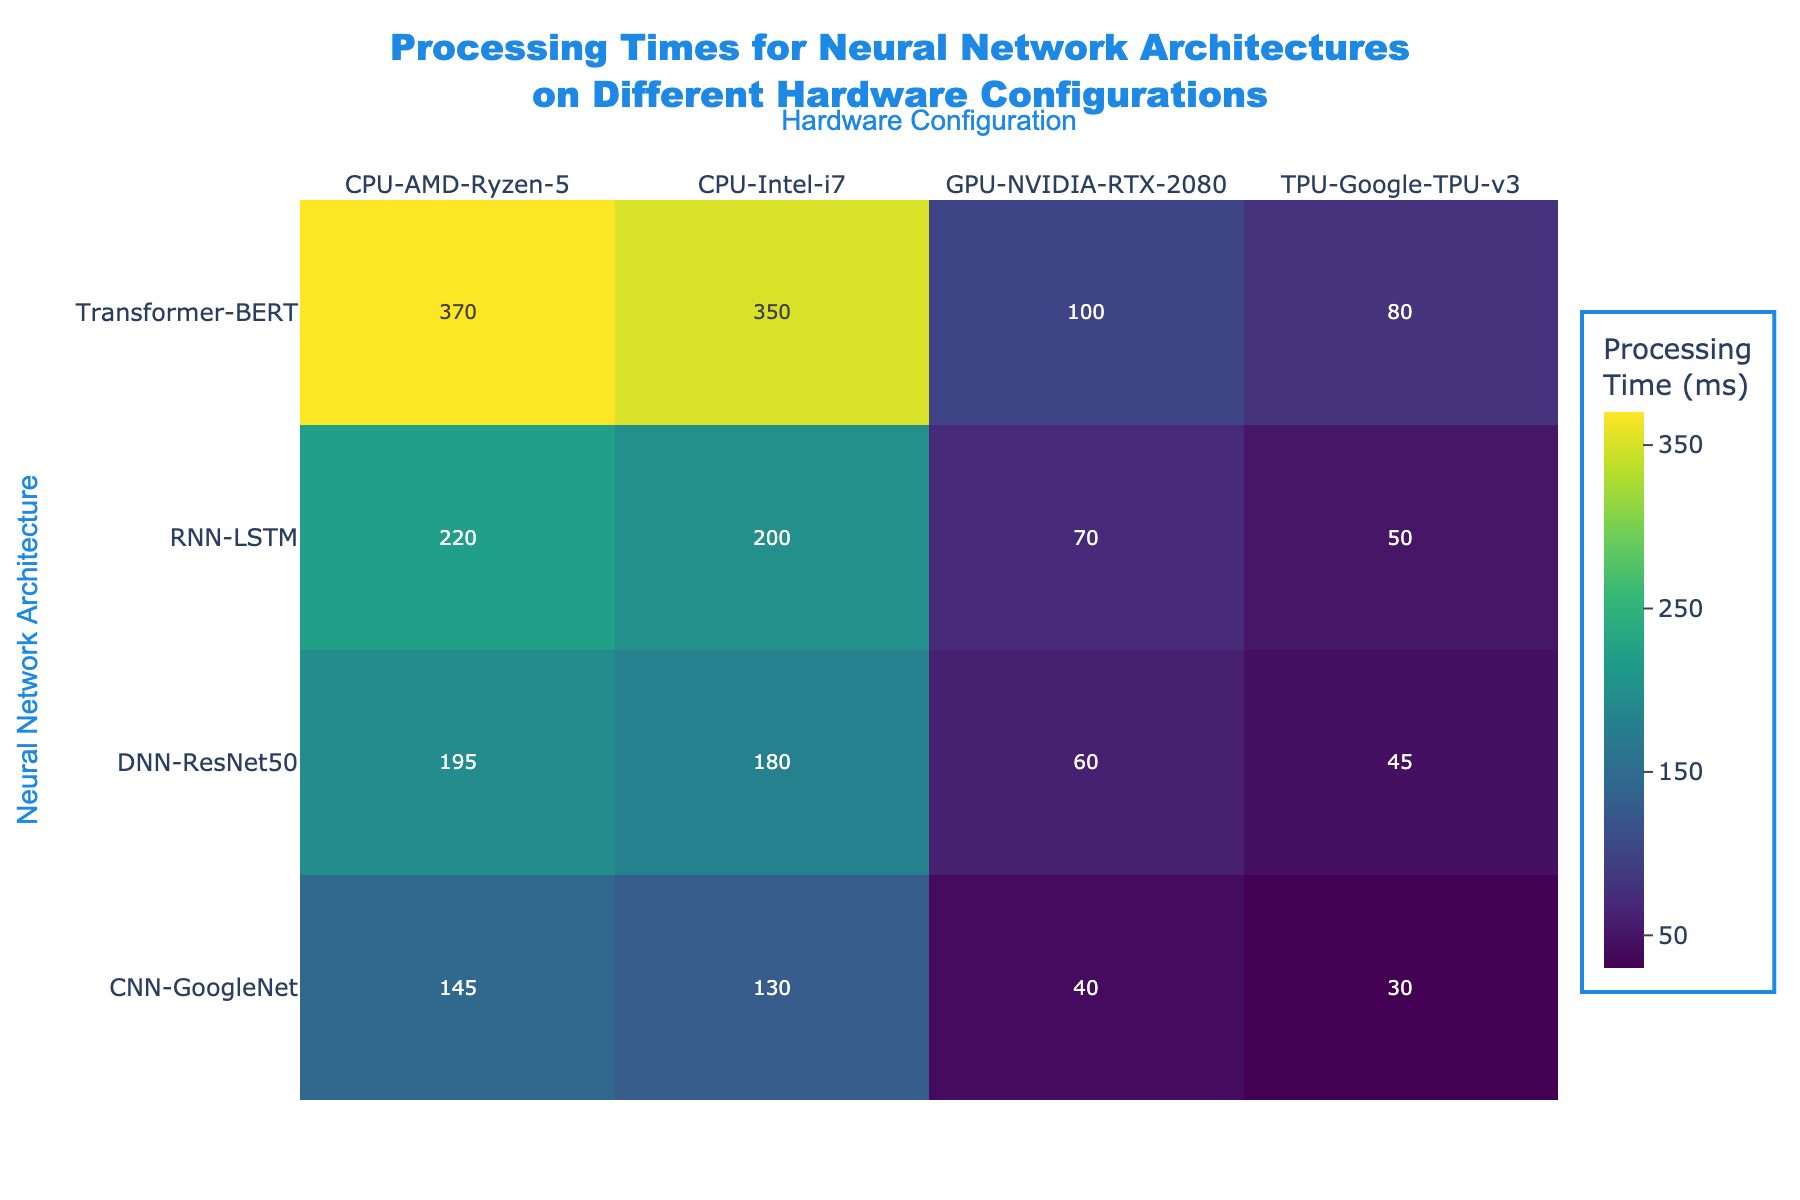What is the Processing Time for the CNN-GoogleNet on TPU-Google-TPU-v3? To find the processing time for CNN-GoogleNet on the TPU-Google-TPU-v3, locate the intersection of the CNN-GoogleNet row and the TPU-Google-TPU-v3 column on the heatmap.
Answer: 30 ms Which Neural Network Architecture has the longest Processing Time on the CPU-Intel-i7? Look down the CPU-Intel-i7 column for the highest value. Transformer-BERT has the longest processing time on CPU-Intel-i7 with 350 ms.
Answer: Transformer-BERT Compare the Processing Times between RNN-LSTM and DNN-ResNet50 using GPU-NVIDIA-RTX-2080. Which one is faster? Identify the values for RNN-LSTM and DNN-ResNet50 in the GPU-NVIDIA-RTX-2080 column. RNN-LSTM has a processing time of 70 ms while DNN-ResNet50 has a processing time of 60 ms. Since 60 ms is less than 70 ms, DNN-ResNet50 is faster.
Answer: DNN-ResNet50 What is the average Processing Time for Transformer-BERT across all hardware configurations? Locate the row for Transformer-BERT and sum all values: 350 + 370 + 100 + 80 = 900. The number of entries is 4, so divide 900 by 4 to get the average time of 225 ms.
Answer: 225 ms Which hardware configuration consistently shows the lowest Processing Times across different Neural Network Architectures? Compare the columns and identify which column mostly has the lowest values. The TPU-Google-TPU-v3 column shows consistently low values across architectures: 30 ms, 50 ms, 80 ms, and 45 ms.
Answer: TPU-Google-TPU-v3 What is the Processing Time difference between CPU-Intel-i7 and CPU-AMD-Ryzen-5 for the DNN-ResNet50 architecture? Locate the processing times for DNN-ResNet50 on CPU-Intel-i7 and CPU-AMD-Ryzen-5: 180 ms and 195 ms, respectively. Calculate the difference: 195 - 180 = 15 ms.
Answer: 15 ms Which Neural Network Architecture has the least variation in Processing Time across all hardware configurations? Calculate the range for each architecture by subtracting the minimum processing time from the maximum. CNN-GoogleNet: 145 - 30 = 115 ms, RNN-LSTM: 220 - 50 = 170 ms, Transformer-BERT: 370 - 80 = 290 ms, DNN-ResNet50: 195 - 45 = 150 ms, and identify the least variation which belongs to CNN-GoogleNet with 115 ms.
Answer: CNN-GoogleNet How does the Processing Time for Transformer-BERT on TPU-Google-TPU-v3 compare to RNN-LSTM on the same hardware? Locate the Transformer-BERT and RNN-LSTM times on TPU-Google-TPU-v3: 80 ms and 50 ms. Compare the two values, indicating RNN-LSTM processes faster on TPU-Google-TPU-v3.
Answer: RNN-LSTM is faster 